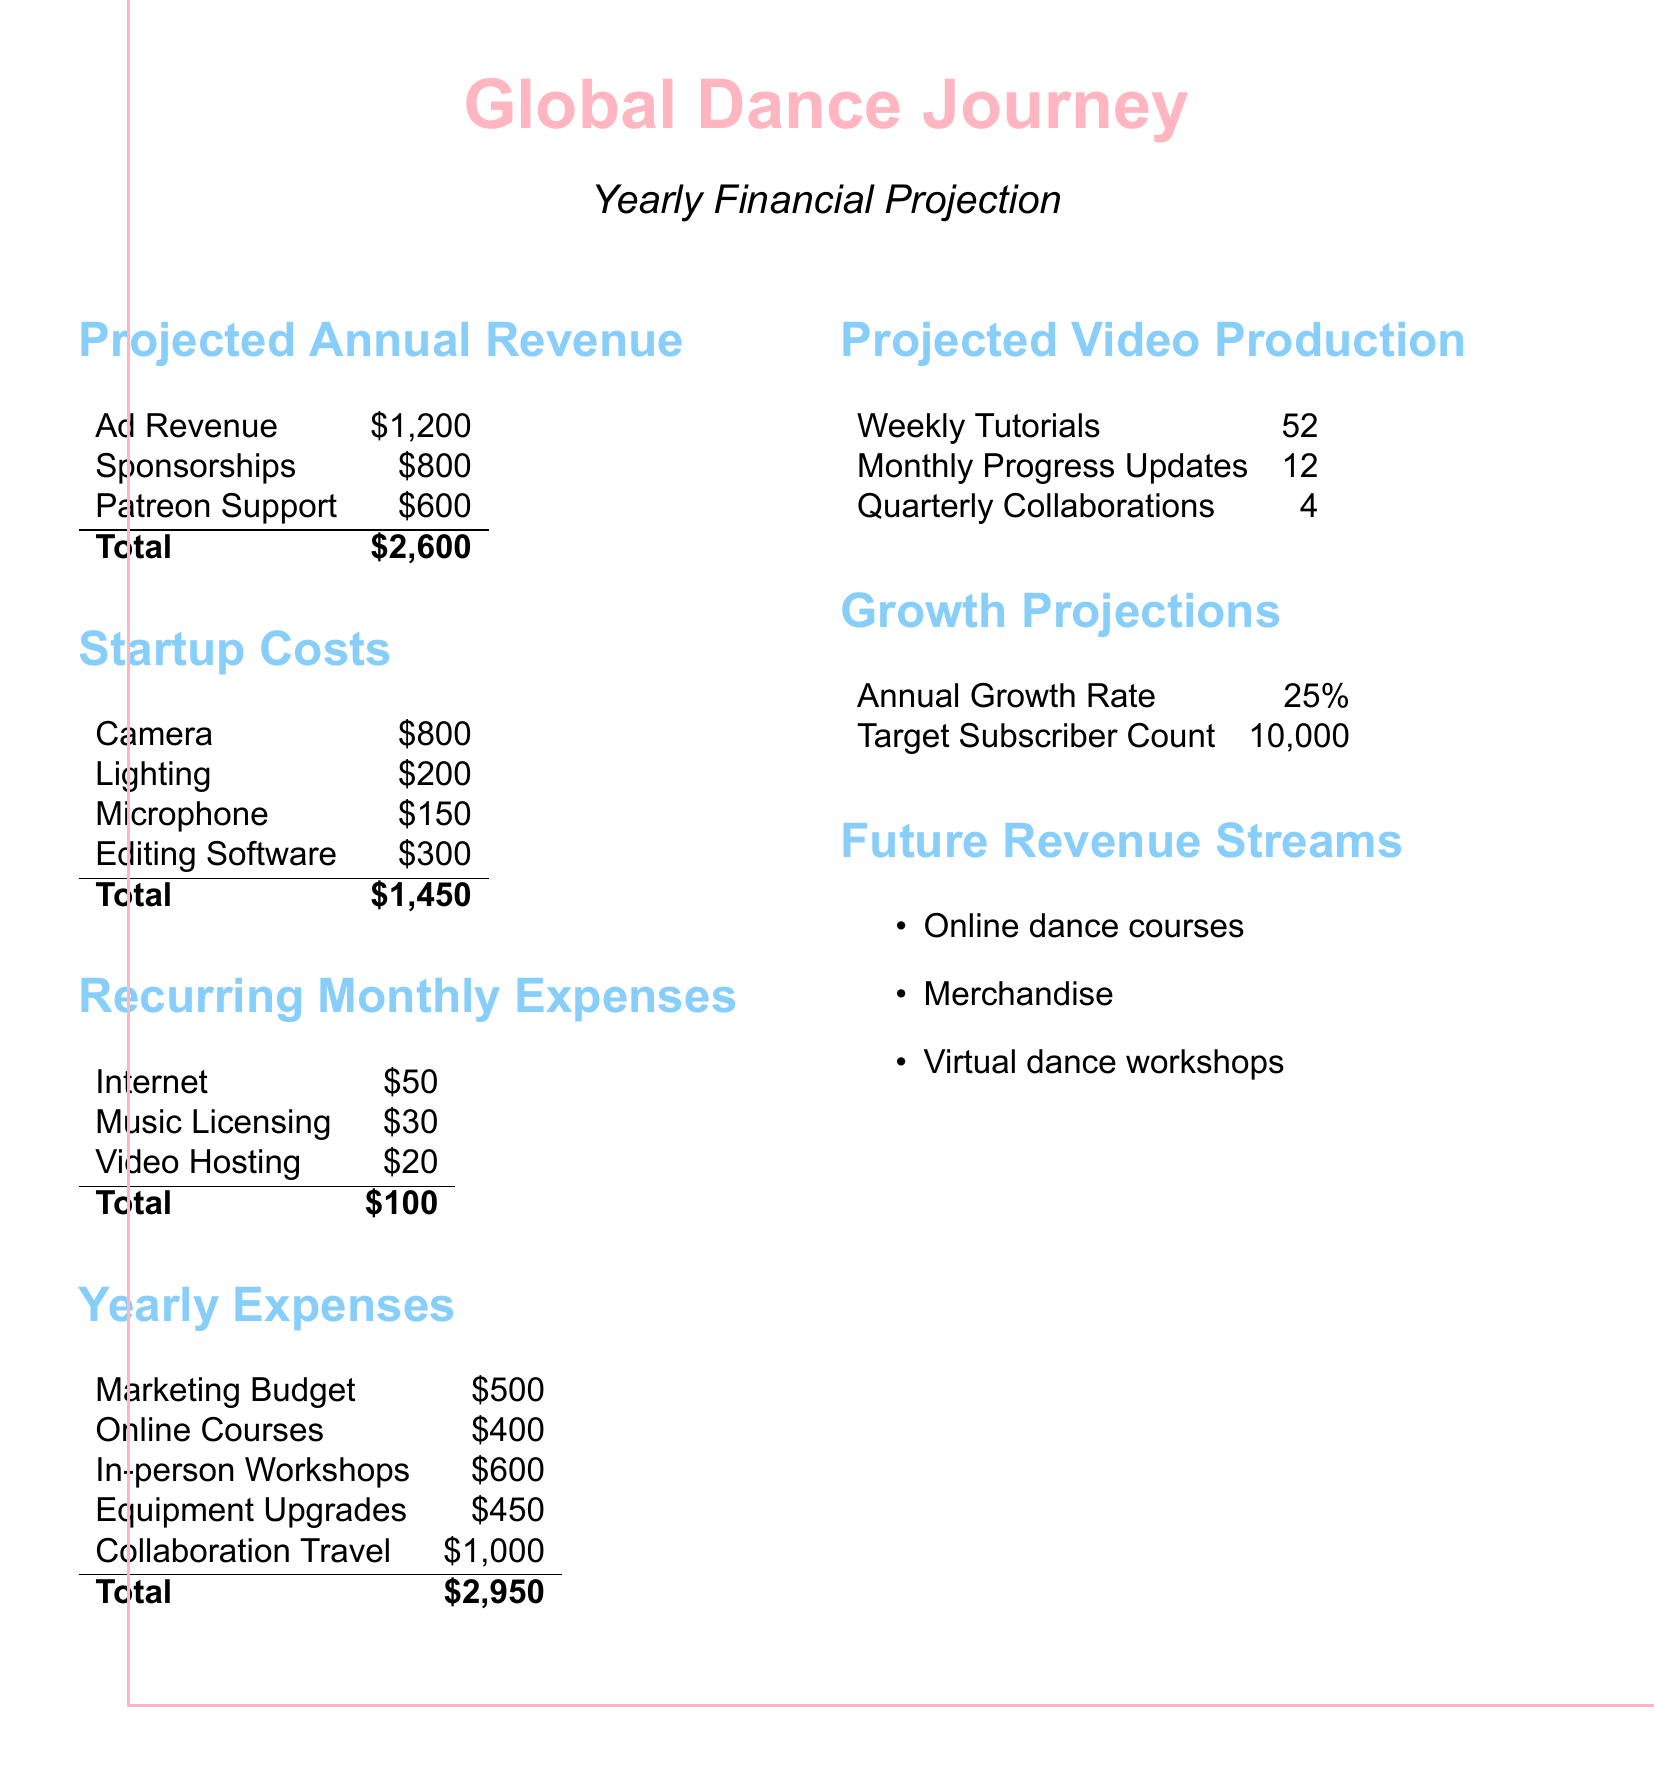what is the total projected annual revenue? The total projected annual revenue is the sum of Ad Revenue, Sponsorships, and Patreon Support, which is $1,200 + $800 + $600.
Answer: $2,600 what is the total startup cost? The total startup cost is the sum of Camera, Lighting, Microphone, and Editing Software, which is $800 + $200 + $150 + $300.
Answer: $1,450 how much is allocated for marketing? The marketing budget is listed as a yearly expense in the document.
Answer: $500 what is the annual growth rate projected? The annual growth rate is explicitly mentioned in the document under Growth Projections.
Answer: 25% how many weekly tutorials are planned? The document specifies the number of Weekly Tutorials planned for the year.
Answer: 52 what is the total yearly expense? The total yearly expenses add up all listed yearly costs, which is $500 + $400 + $600 + $450 + $1,000.
Answer: $2,950 how many collaborations are planned quarterly? The document mentions the number of Quarterly Collaborations planned for the year.
Answer: 4 what is the target subscriber count? The target subscriber count is listed in the Growth Projections section of the document.
Answer: 10,000 what type of future revenue streams are identified? The document lists several potential future revenue streams under Future Revenue Streams.
Answer: Online dance courses, Merchandise, Virtual dance workshops 